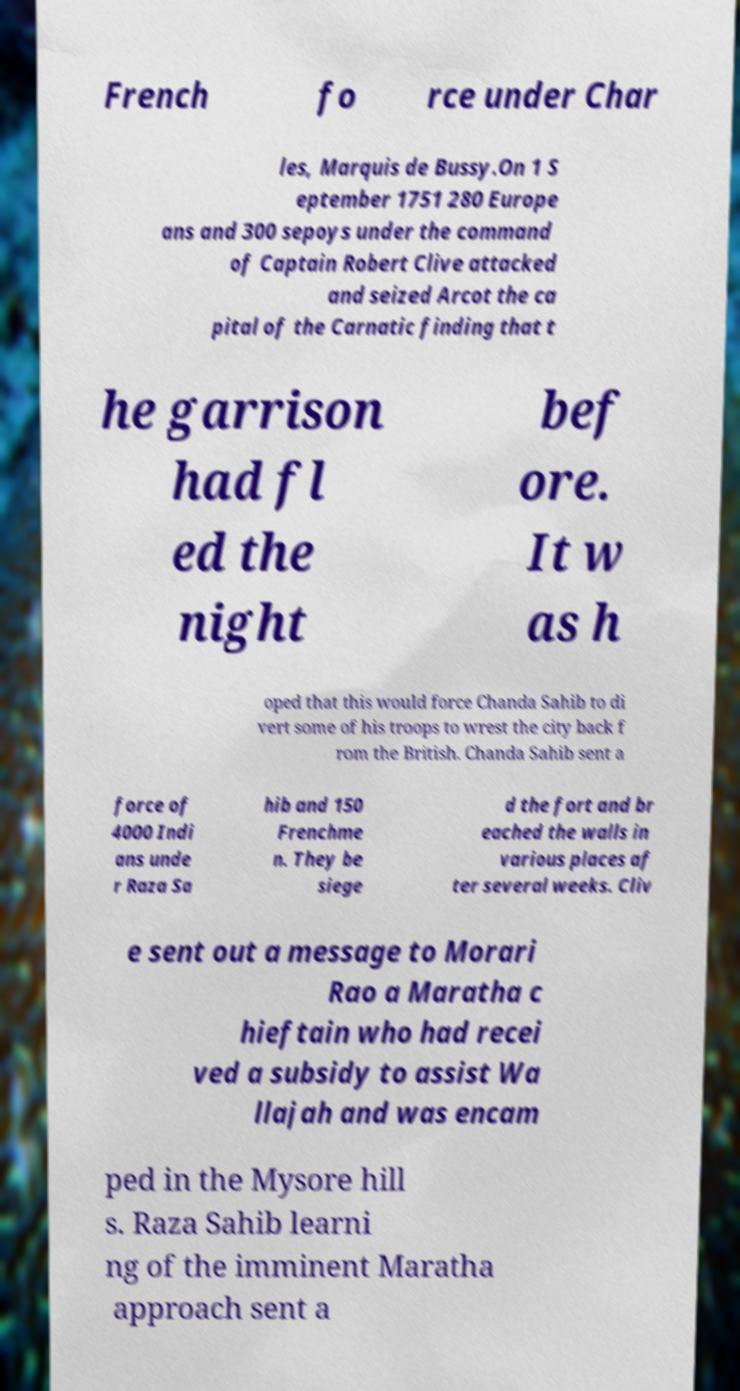Could you extract and type out the text from this image? French fo rce under Char les, Marquis de Bussy.On 1 S eptember 1751 280 Europe ans and 300 sepoys under the command of Captain Robert Clive attacked and seized Arcot the ca pital of the Carnatic finding that t he garrison had fl ed the night bef ore. It w as h oped that this would force Chanda Sahib to di vert some of his troops to wrest the city back f rom the British. Chanda Sahib sent a force of 4000 Indi ans unde r Raza Sa hib and 150 Frenchme n. They be siege d the fort and br eached the walls in various places af ter several weeks. Cliv e sent out a message to Morari Rao a Maratha c hieftain who had recei ved a subsidy to assist Wa llajah and was encam ped in the Mysore hill s. Raza Sahib learni ng of the imminent Maratha approach sent a 